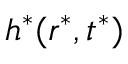<formula> <loc_0><loc_0><loc_500><loc_500>h ^ { * } ( r ^ { * } , t ^ { * } )</formula> 